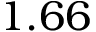Convert formula to latex. <formula><loc_0><loc_0><loc_500><loc_500>1 . 6 6</formula> 